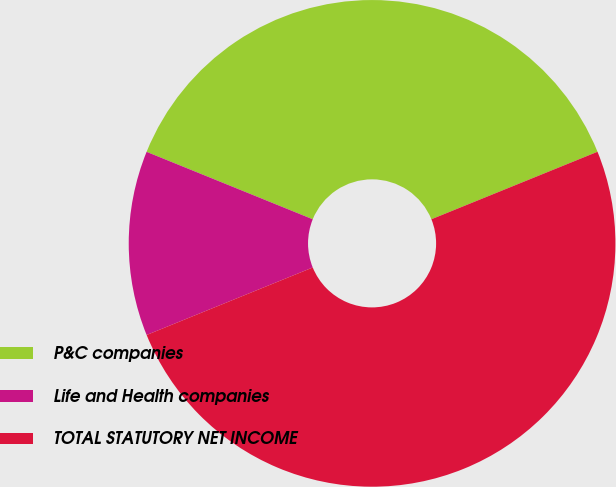Convert chart to OTSL. <chart><loc_0><loc_0><loc_500><loc_500><pie_chart><fcel>P&C companies<fcel>Life and Health companies<fcel>TOTAL STATUTORY NET INCOME<nl><fcel>37.72%<fcel>12.28%<fcel>50.0%<nl></chart> 